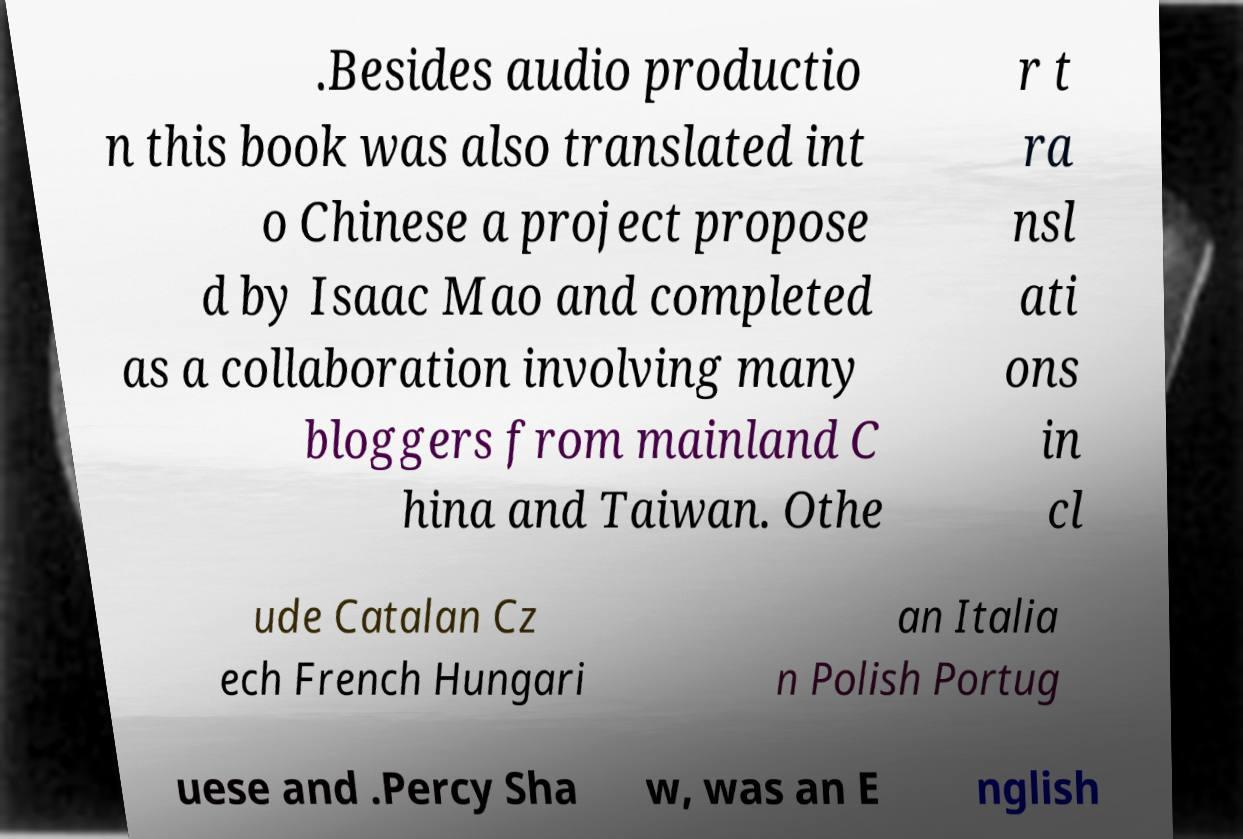There's text embedded in this image that I need extracted. Can you transcribe it verbatim? .Besides audio productio n this book was also translated int o Chinese a project propose d by Isaac Mao and completed as a collaboration involving many bloggers from mainland C hina and Taiwan. Othe r t ra nsl ati ons in cl ude Catalan Cz ech French Hungari an Italia n Polish Portug uese and .Percy Sha w, was an E nglish 